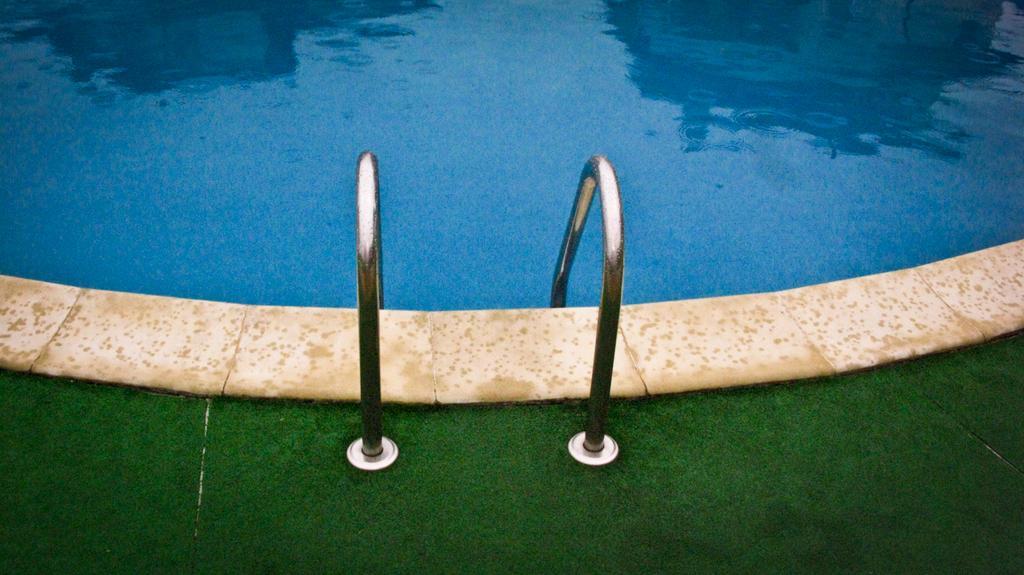In one or two sentences, can you explain what this image depicts? In this picture we can observe a swimming pool. There are two railings. We can observe a grass mat hire. 